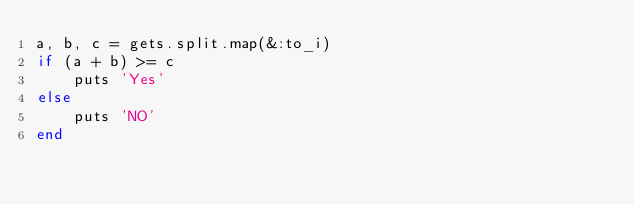Convert code to text. <code><loc_0><loc_0><loc_500><loc_500><_Ruby_>a, b, c = gets.split.map(&:to_i)
if (a + b) >= c
    puts 'Yes'
else
    puts 'NO'
end</code> 